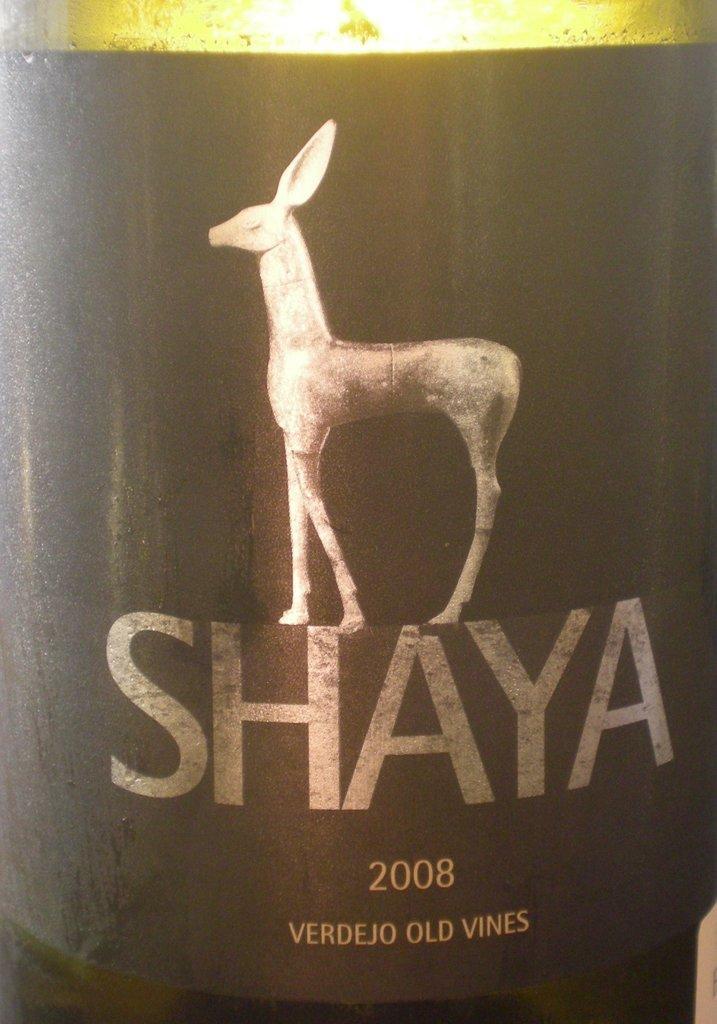How would you summarize this image in a sentence or two? In this picture, we can a poster with some text and image on an object. 